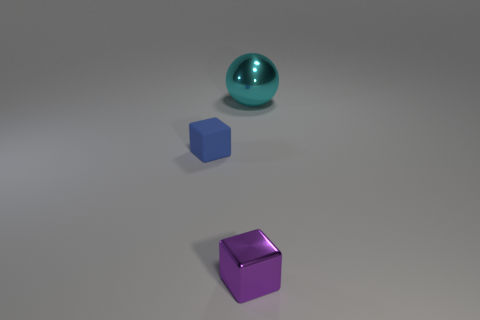Add 3 big cyan metallic things. How many objects exist? 6 Subtract all blocks. How many objects are left? 1 Add 1 small purple shiny objects. How many small purple shiny objects are left? 2 Add 2 big cyan metal objects. How many big cyan metal objects exist? 3 Subtract 0 red cubes. How many objects are left? 3 Subtract all blue cubes. Subtract all purple objects. How many objects are left? 1 